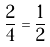<formula> <loc_0><loc_0><loc_500><loc_500>\frac { 2 } { 4 } = \frac { 1 } { 2 }</formula> 